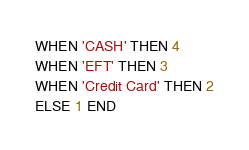<code> <loc_0><loc_0><loc_500><loc_500><_SQL_>WHEN 'CASH' THEN 4
WHEN 'EFT' THEN 3
WHEN 'Credit Card' THEN 2
ELSE 1 END 
</code> 